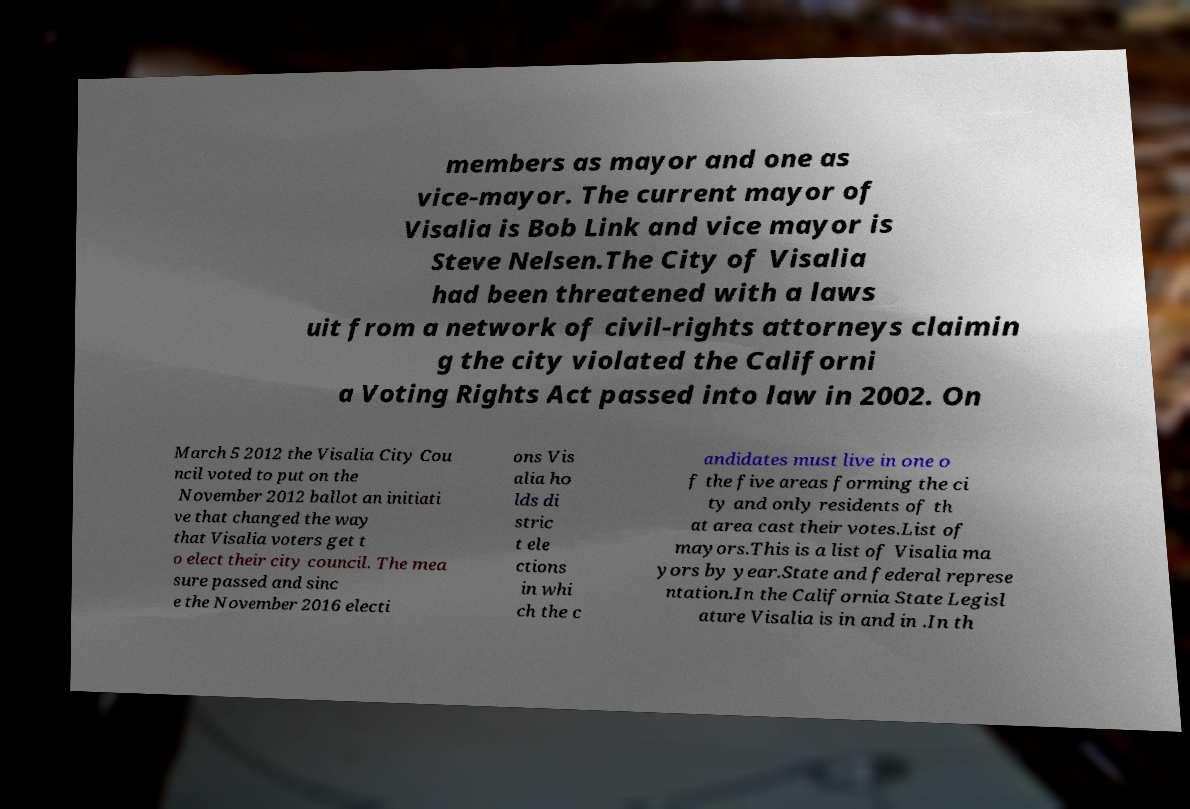Can you read and provide the text displayed in the image?This photo seems to have some interesting text. Can you extract and type it out for me? members as mayor and one as vice-mayor. The current mayor of Visalia is Bob Link and vice mayor is Steve Nelsen.The City of Visalia had been threatened with a laws uit from a network of civil-rights attorneys claimin g the city violated the Californi a Voting Rights Act passed into law in 2002. On March 5 2012 the Visalia City Cou ncil voted to put on the November 2012 ballot an initiati ve that changed the way that Visalia voters get t o elect their city council. The mea sure passed and sinc e the November 2016 electi ons Vis alia ho lds di stric t ele ctions in whi ch the c andidates must live in one o f the five areas forming the ci ty and only residents of th at area cast their votes.List of mayors.This is a list of Visalia ma yors by year.State and federal represe ntation.In the California State Legisl ature Visalia is in and in .In th 